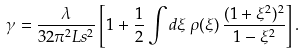<formula> <loc_0><loc_0><loc_500><loc_500>\gamma = \frac { \lambda } { 3 2 \pi ^ { 2 } L s ^ { 2 } } \left [ 1 + \frac { 1 } { 2 } \int d \xi \, \rho ( \xi ) \, \frac { ( 1 + \xi ^ { 2 } ) ^ { 2 } } { 1 - \xi ^ { 2 } } \right ] .</formula> 